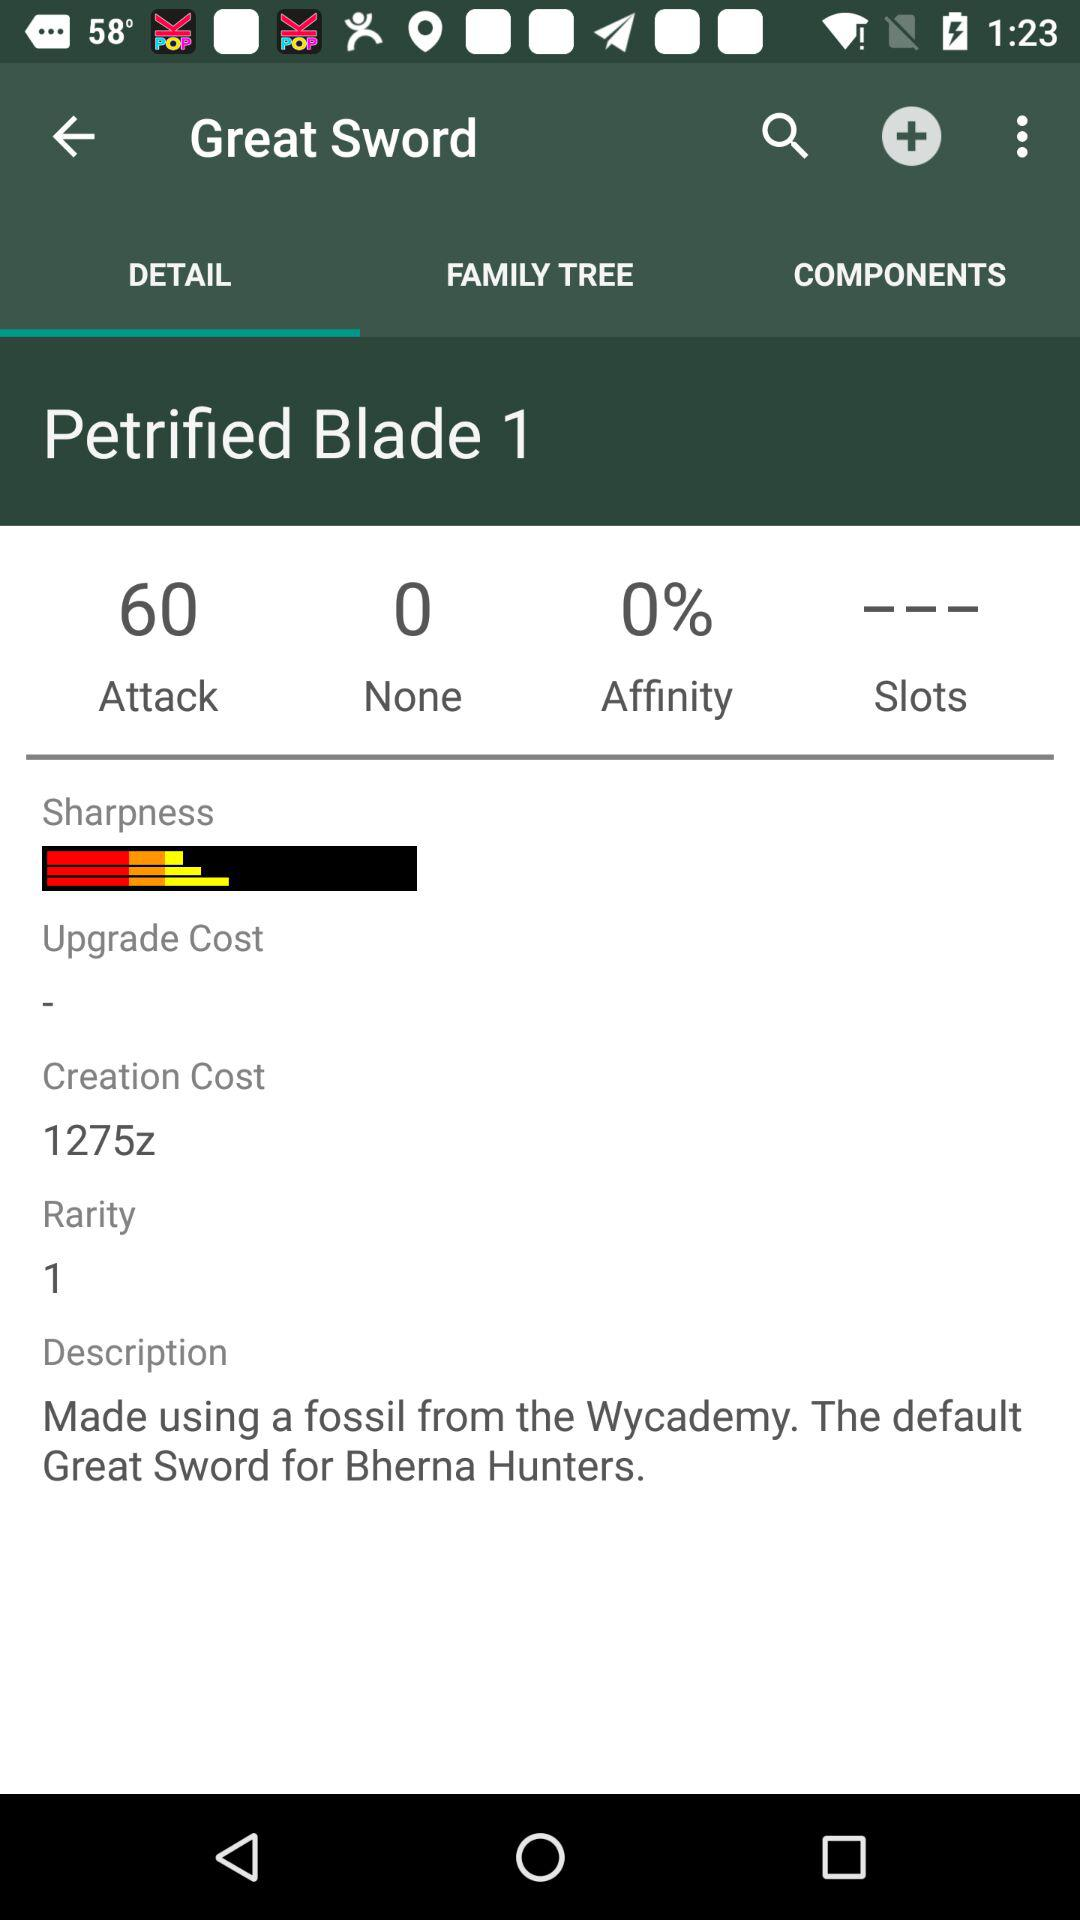How many petrified blades are there in the Great Sword?
When the provided information is insufficient, respond with <no answer>. <no answer> 